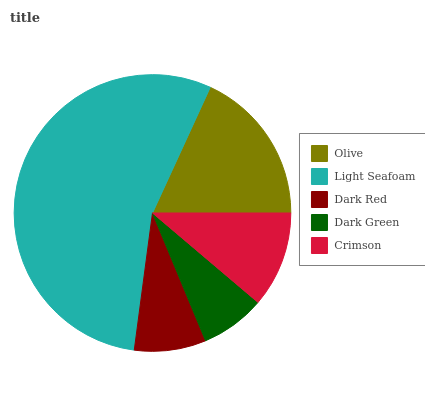Is Dark Green the minimum?
Answer yes or no. Yes. Is Light Seafoam the maximum?
Answer yes or no. Yes. Is Dark Red the minimum?
Answer yes or no. No. Is Dark Red the maximum?
Answer yes or no. No. Is Light Seafoam greater than Dark Red?
Answer yes or no. Yes. Is Dark Red less than Light Seafoam?
Answer yes or no. Yes. Is Dark Red greater than Light Seafoam?
Answer yes or no. No. Is Light Seafoam less than Dark Red?
Answer yes or no. No. Is Crimson the high median?
Answer yes or no. Yes. Is Crimson the low median?
Answer yes or no. Yes. Is Olive the high median?
Answer yes or no. No. Is Dark Green the low median?
Answer yes or no. No. 